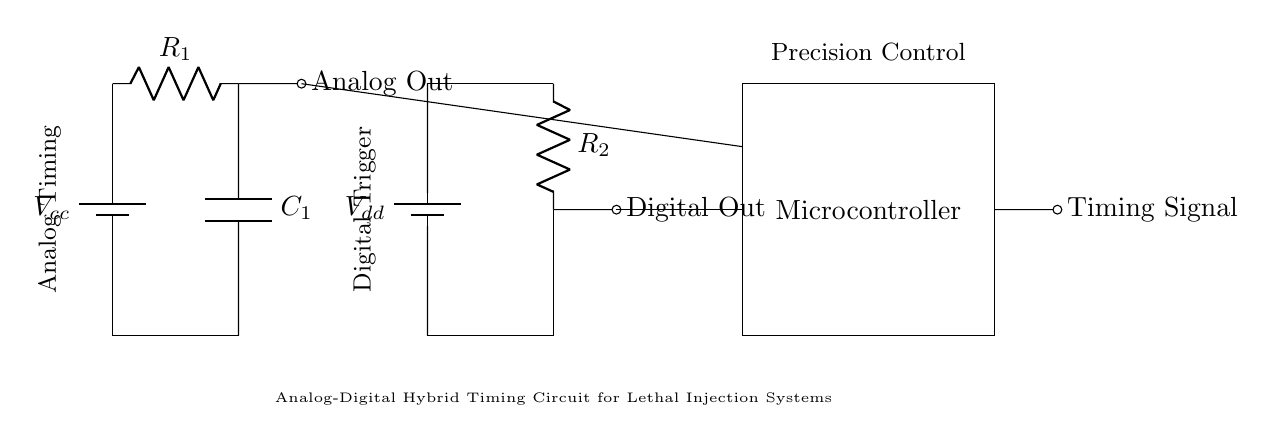What is the role of C1 in this circuit? C1 is a capacitor that is used for timing purposes, controlling the charge and discharge cycles for precise measurement in the analog timing section of the circuit.
Answer: Timing What is the output of the microcontroller? The microcontroller generates a timing signal which acts as the final output of the hybrid timing circuit.
Answer: Timing Signal What type of component is R2? R2 is a resistor that contributes to the digital triggering mechanism within the circuit, affecting the behavior of the digital output.
Answer: Resistor How many powering sources are present in the circuit? There are two power sources, Vcc for the analog section and Vdd for the digital section, providing necessary voltage for the operation of respective parts.
Answer: Two What type of control does the circuit provide? The circuit provides precision control over the timing mechanisms, allowing for accurate measurements crucial in lethal injection systems.
Answer: Precision Control What is the significance of the connections from the analog and digital parts to the microcontroller? The connections to the microcontroller allow it to process the outputs from both the analog and digital sections, enabling coordinated timing control for the lethal injection process.
Answer: Coordinated Control What distinguishes this circuit as a hybrid? This circuit is hybrid because it combines both analog and digital components, utilizing their strengths for better timing and triggering functionality in the lethal injection system.
Answer: Analog-Digital Combination 